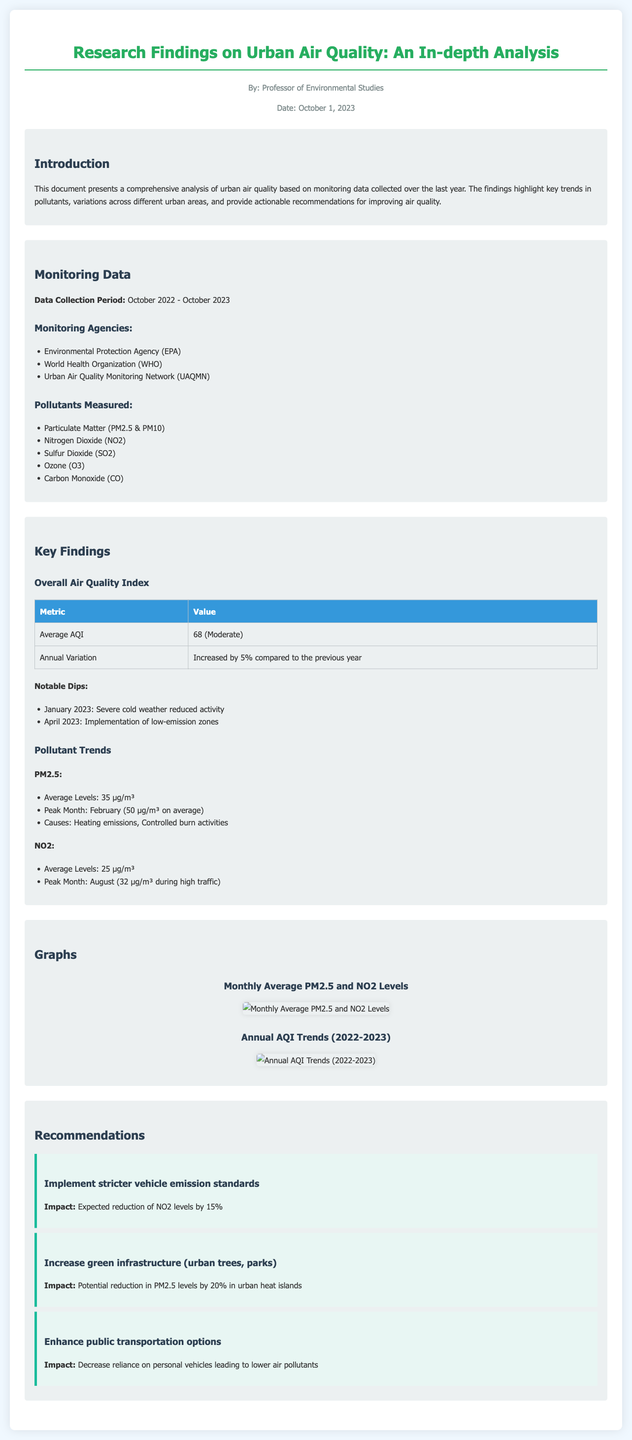what is the average AQI reported in the findings? The average AQI is shown in the "Overall Air Quality Index" section, which states it is 68.
Answer: 68 what is the peak month for PM2.5 levels? The peak month is identified in the "Pollutant Trends" section under PM2.5, which indicates February as the peak month.
Answer: February how much did the annual variation of AQI increase compared to the previous year? The document mentions an increase in annual variation of AQI by 5% in the "Overall Air Quality Index" section.
Answer: 5% which pollutant has an average level of 25 µg/m³? The "Pollutant Trends" section for NO2 indicates its average level as 25 µg/m³.
Answer: Nitrogen Dioxide (NO2) what is one major cause of PM2.5 levels being high? The "Pollutant Trends" section for PM2.5 lists heating emissions as one of the causes.
Answer: Heating emissions what action is recommended to reduce PM2.5 levels in urban heat islands? The recommendations highlight increasing green infrastructure to reduce PM2.5 levels in urban heat islands.
Answer: Increase green infrastructure (urban trees, parks) who collected the air quality monitoring data? The "Monitoring Agencies" section lists agencies like the Environmental Protection Agency (EPA) as data collectors.
Answer: Environmental Protection Agency (EPA) what was a notable dip in air quality attributed to? The "Notable Dips" section notes that severe cold weather reduced activity in January 2023.
Answer: Severe cold weather 